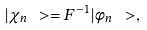Convert formula to latex. <formula><loc_0><loc_0><loc_500><loc_500>| \chi _ { n } \ > = F ^ { - 1 } | \phi _ { n } \ > ,</formula> 